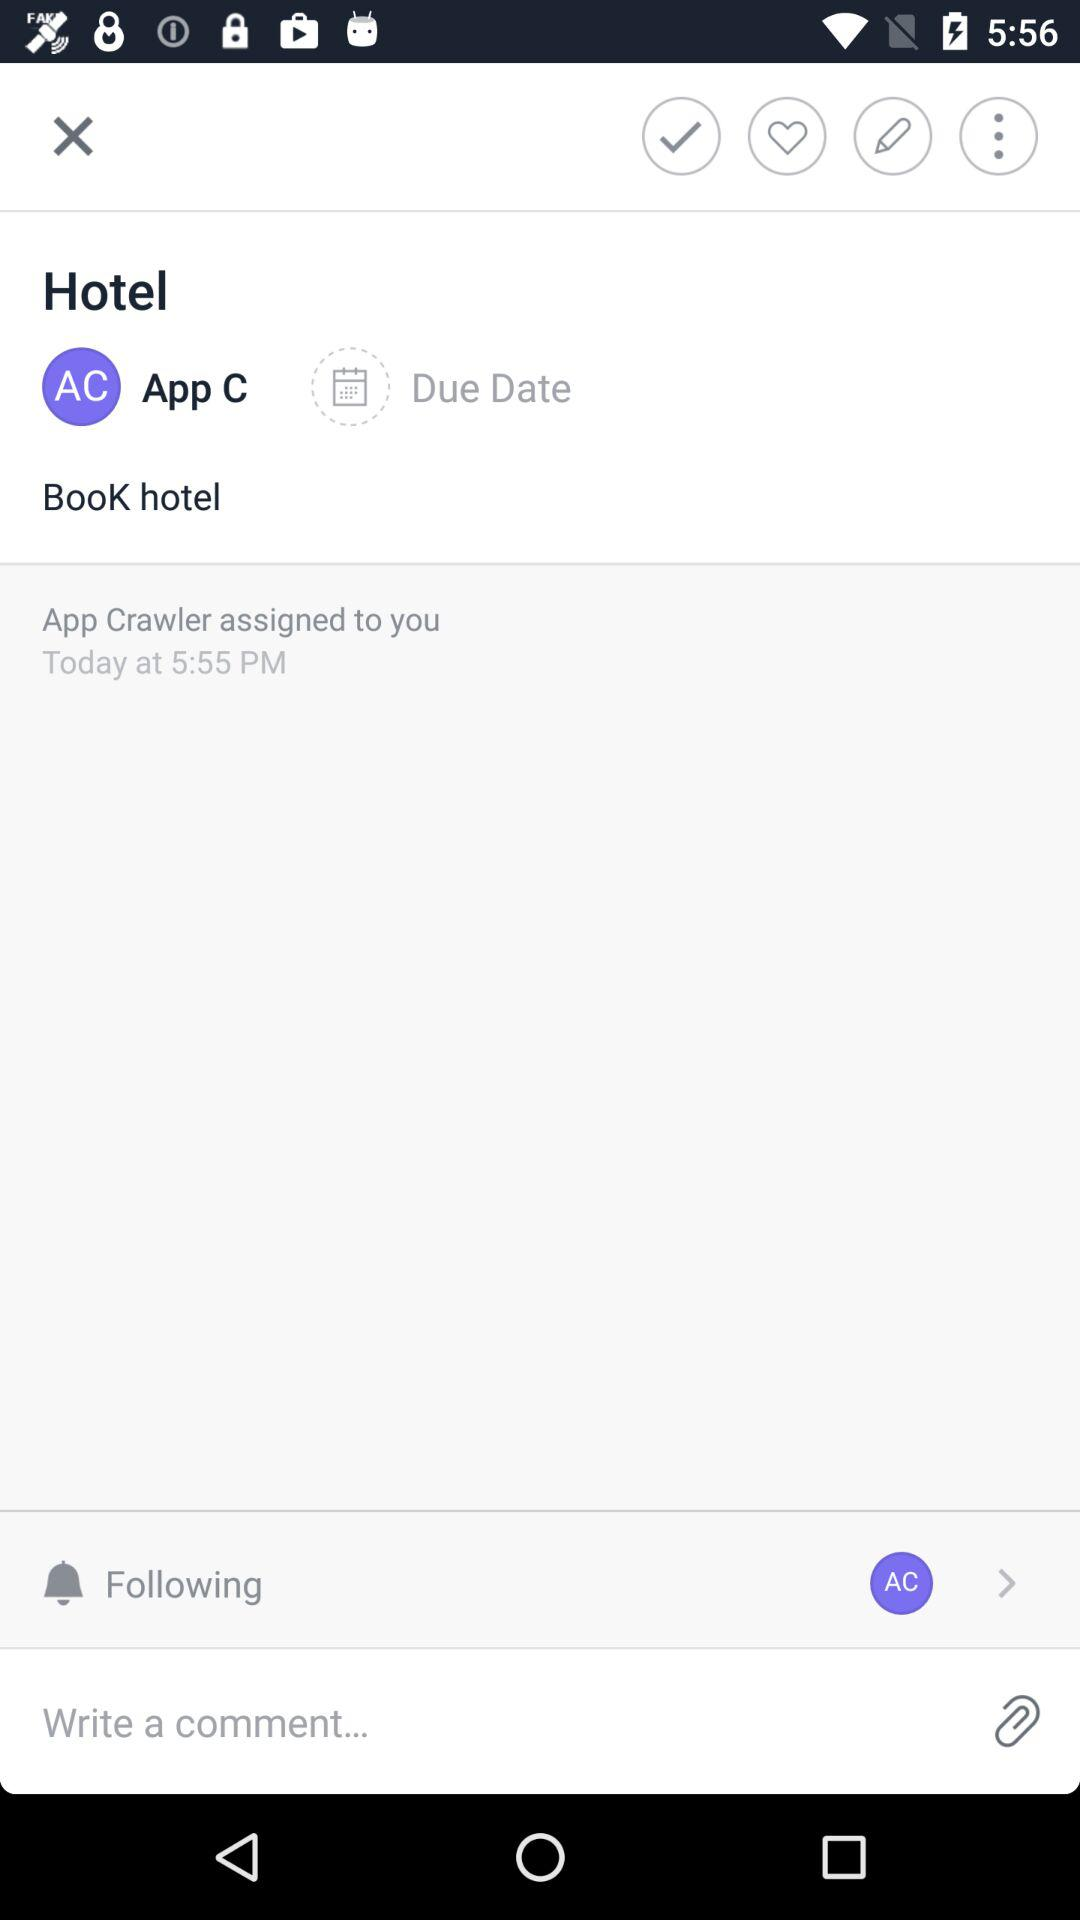Which option is selected? The selected option is "App C". 